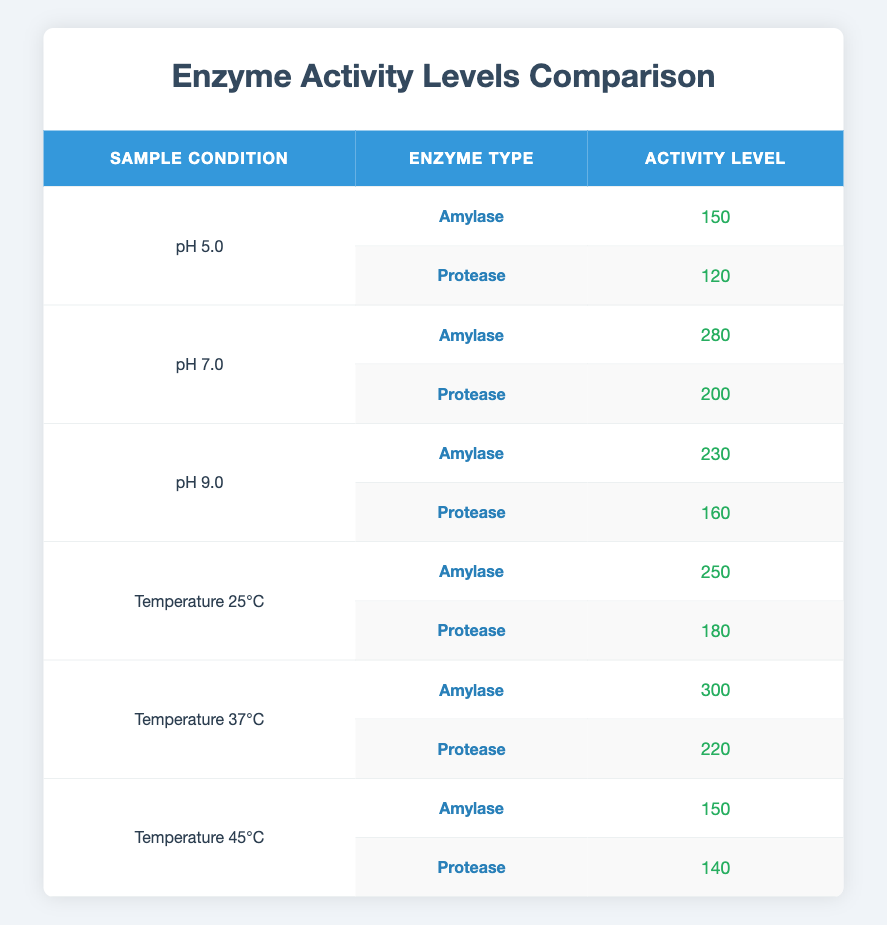What is the activity level of Amylase at pH 7.0? From the table, locate the row where the Sample Condition is pH 7.0 and the Enzyme Type is Amylase. The Activity Level listed there is 280.
Answer: 280 What is the activity level of Protease at pH 9.0? In the table, find the row with Sample Condition pH 9.0 and Enzyme Type Protease. The corresponding Activity Level is 160.
Answer: 160 What are the average activity levels of Amylase across all sample conditions? To calculate the average for Amylase, sum the Activity Levels: 150 (pH 5.0) + 280 (pH 7.0) + 230 (pH 9.0) + 250 (Temperature 25°C) + 300 (Temperature 37°C) + 150 (Temperature 45°C) = 1360. There are 6 conditions, thus the average is 1360 / 6 = 226.67.
Answer: 226.67 Is the activity level of Protease at Temperature 37°C higher than that at Temperature 25°C? Check the table for the Activity Level of Protease at both temperatures. At Temperature 37°C, it is 220, and at Temperature 25°C, it is 180. Since 220 > 180, the answer is yes.
Answer: Yes What is the total enzyme activity level at pH 5.0? To find the total activity at pH 5.0, you need to add the Activity Levels for both Amylase and Protease: 150 (Amylase) + 120 (Protease) = 270.
Answer: 270 Which enzyme has the highest activity level and what is that value? Examine the table to identify each enzyme's activity levels, identifying Amylase (300 at Temperature 37°C) as the highest. Thus, the highest activity level is 300.
Answer: 300 At pH 7.0, which enzyme has a higher activity level? Look at the Activity Levels at pH 7.0 for Amylase (280) and Protease (200). Since 280 > 200, Amylase has the higher activity level.
Answer: Amylase Is the statement 'Protease has a consistent activity level across different sample conditions' true? Check the activity levels of Protease across all conditions: 120 (pH 5.0), 200 (pH 7.0), 160 (pH 9.0), 180 (Temperature 25°C), 220 (Temperature 37°C), and 140 (Temperature 45°C). The values are not consistent, showing variation.
Answer: No 